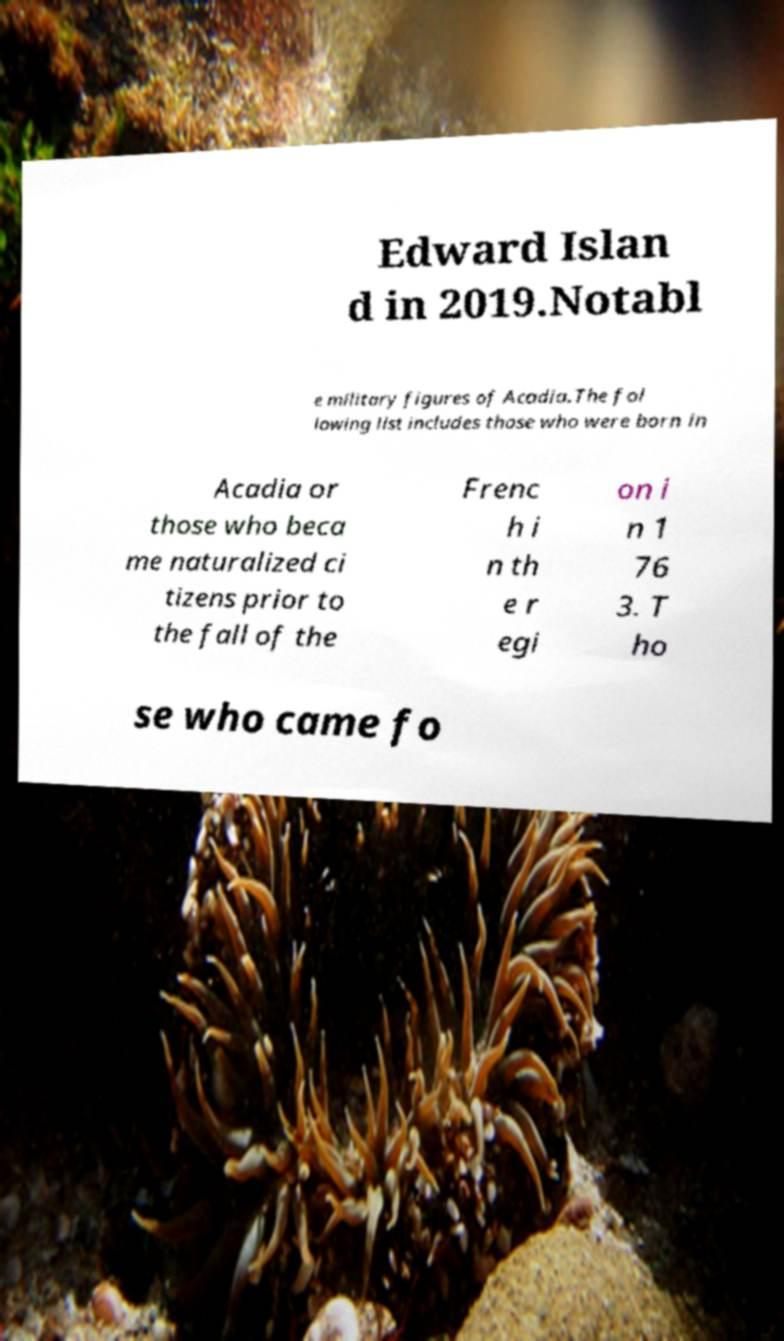There's text embedded in this image that I need extracted. Can you transcribe it verbatim? Edward Islan d in 2019.Notabl e military figures of Acadia.The fol lowing list includes those who were born in Acadia or those who beca me naturalized ci tizens prior to the fall of the Frenc h i n th e r egi on i n 1 76 3. T ho se who came fo 